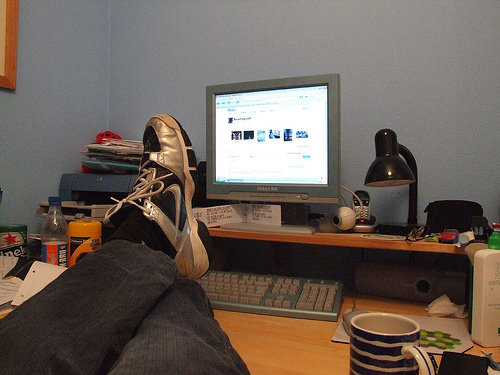<image>
Can you confirm if the keyboard is under the table? No. The keyboard is not positioned under the table. The vertical relationship between these objects is different. Is there a computer in front of the man? Yes. The computer is positioned in front of the man, appearing closer to the camera viewpoint. 